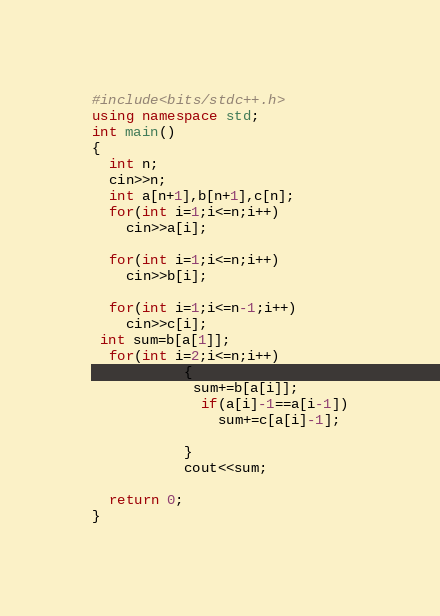<code> <loc_0><loc_0><loc_500><loc_500><_C++_>#include<bits/stdc++.h>
using namespace std;
int main()
{
  int n;
  cin>>n;
  int a[n+1],b[n+1],c[n];
  for(int i=1;i<=n;i++)
    cin>>a[i];
  
  for(int i=1;i<=n;i++)
    cin>>b[i];
  
  for(int i=1;i<=n-1;i++)
    cin>>c[i];
 int sum=b[a[1]];
  for(int i=2;i<=n;i++)
           {
            sum+=b[a[i]];
             if(a[i]-1==a[i-1])
               sum+=c[a[i]-1];
             
           }
           cout<<sum;
             
  return 0;
}</code> 